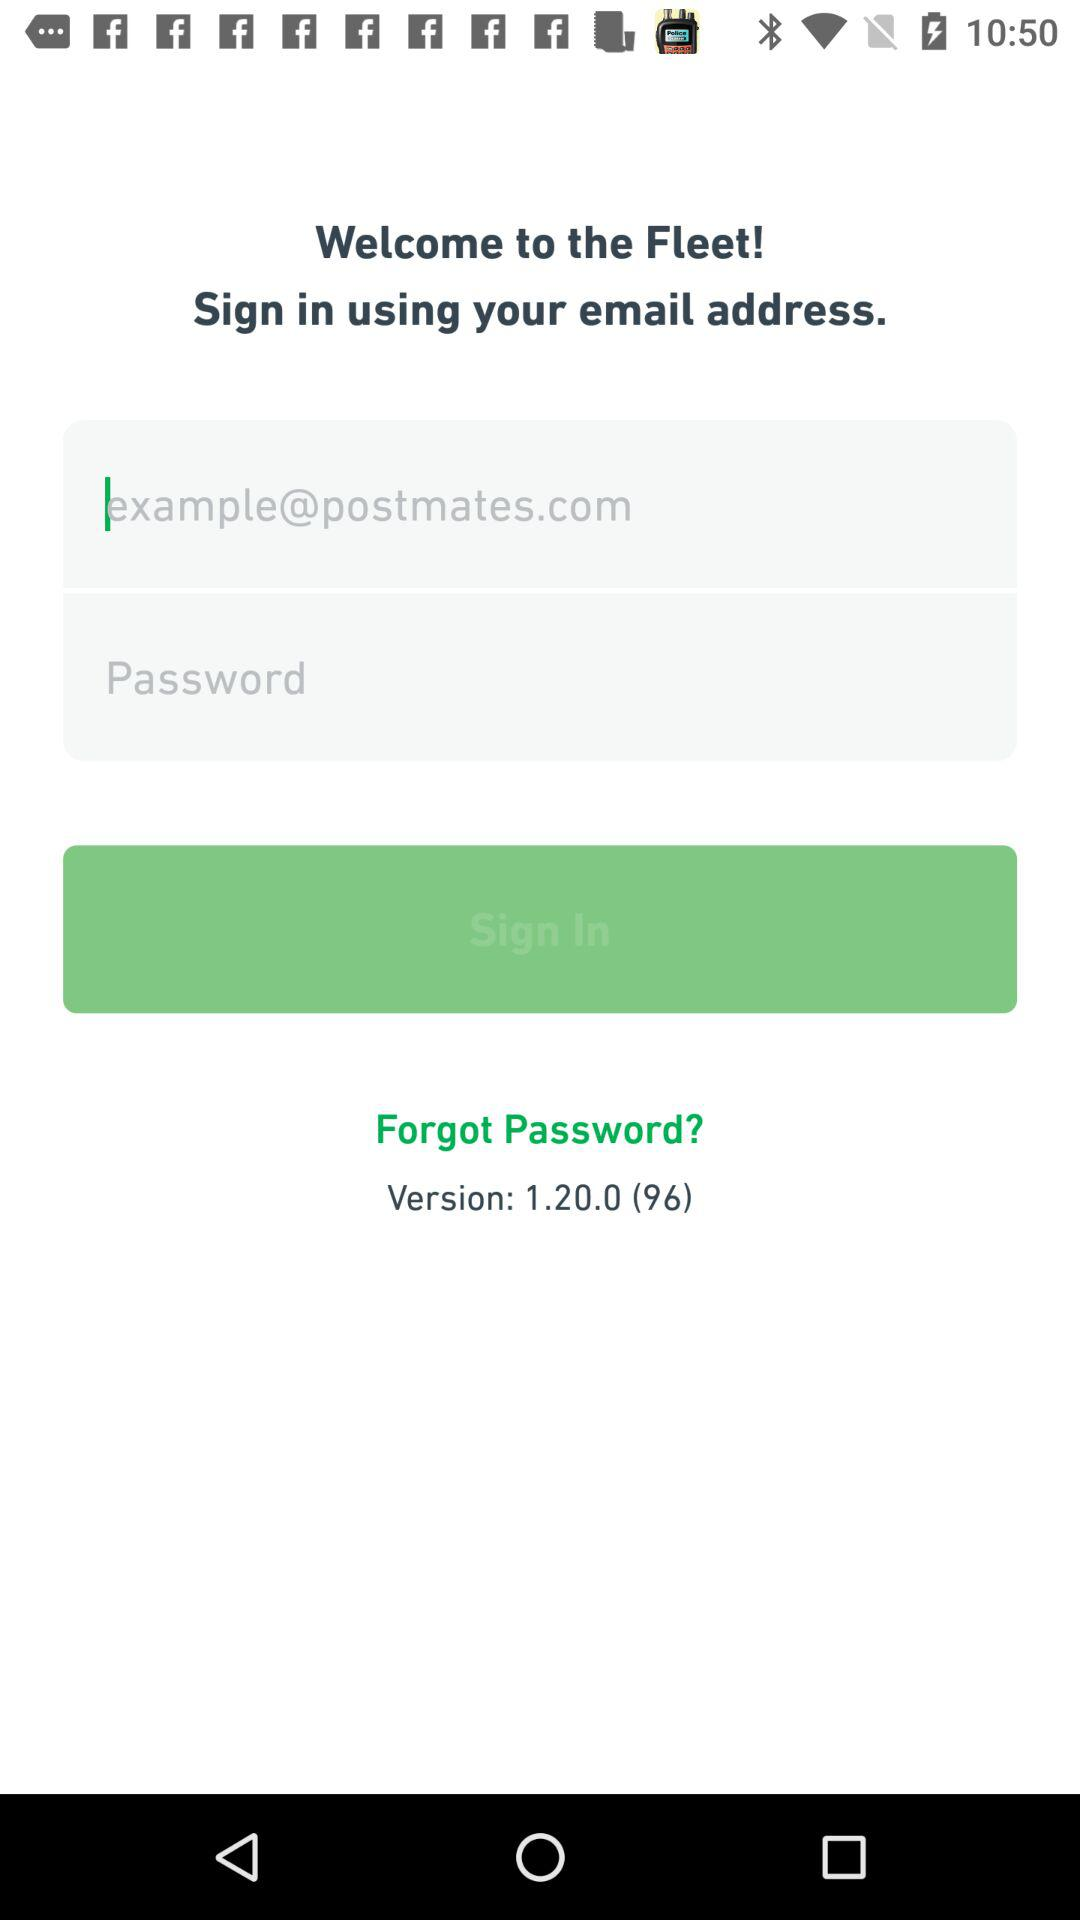What is the email address? The email address is "example@postmates.com". 